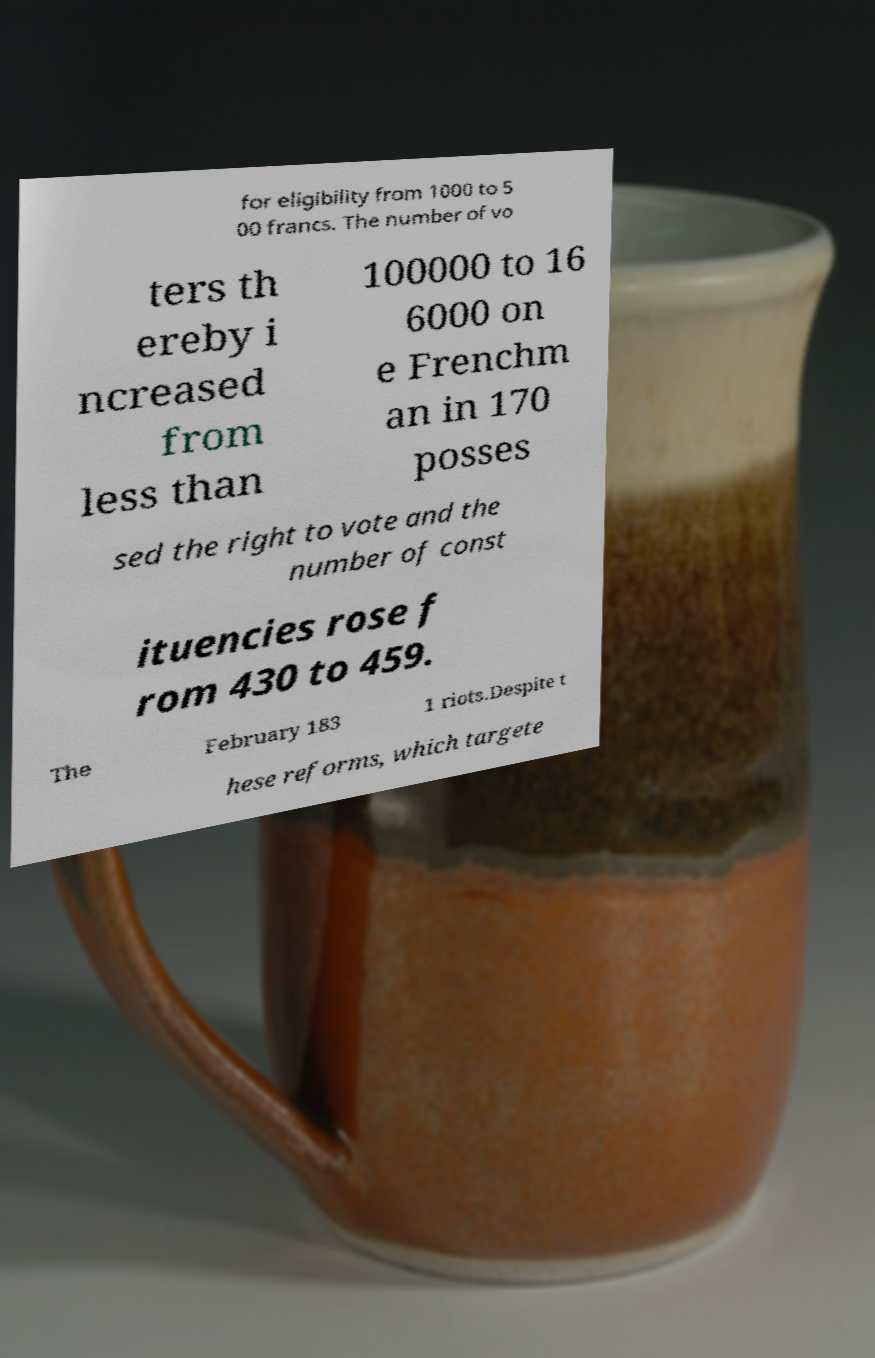Can you read and provide the text displayed in the image?This photo seems to have some interesting text. Can you extract and type it out for me? for eligibility from 1000 to 5 00 francs. The number of vo ters th ereby i ncreased from less than 100000 to 16 6000 on e Frenchm an in 170 posses sed the right to vote and the number of const ituencies rose f rom 430 to 459. The February 183 1 riots.Despite t hese reforms, which targete 